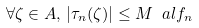<formula> <loc_0><loc_0><loc_500><loc_500>\forall \zeta \in A , \, | \tau _ { n } ( \zeta ) | \leq M \ a l f _ { n }</formula> 